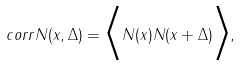<formula> <loc_0><loc_0><loc_500><loc_500>c o r r N ( x , \Delta ) = \Big < N ( x ) N ( x + \Delta ) \Big > ,</formula> 